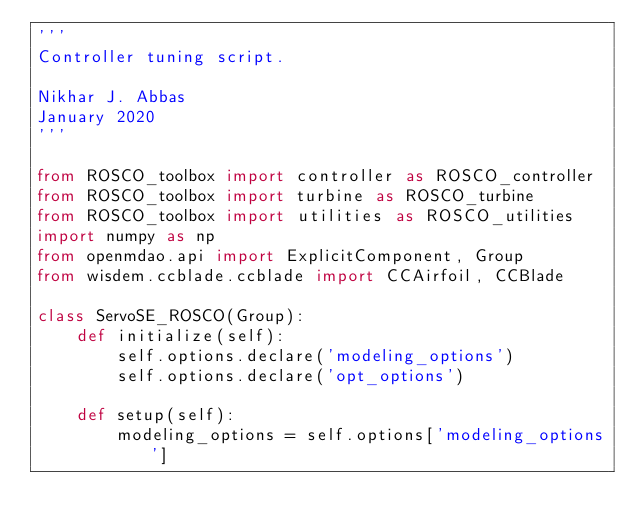Convert code to text. <code><loc_0><loc_0><loc_500><loc_500><_Python_>'''
Controller tuning script.

Nikhar J. Abbas
January 2020
'''

from ROSCO_toolbox import controller as ROSCO_controller
from ROSCO_toolbox import turbine as ROSCO_turbine
from ROSCO_toolbox import utilities as ROSCO_utilities
import numpy as np
from openmdao.api import ExplicitComponent, Group
from wisdem.ccblade.ccblade import CCAirfoil, CCBlade

class ServoSE_ROSCO(Group):
    def initialize(self):
        self.options.declare('modeling_options')
        self.options.declare('opt_options')

    def setup(self):
        modeling_options = self.options['modeling_options']
</code> 